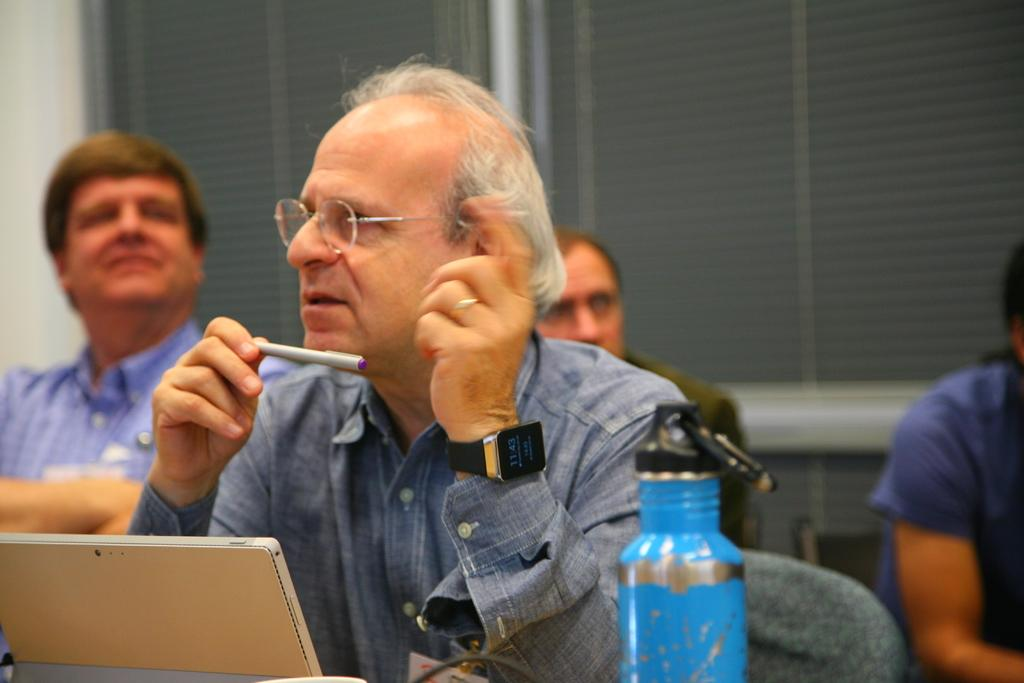What is the man in the image doing? The man is sitting on a chair in the image. Who or what is the man looking at? The man is looking at someone. Can you describe the people in the background of the image? There are three people in the background of the image. What type of crayon is the man using to draw in the image? There is no crayon or drawing activity present in the image. What activity are the waves participating in the image? There are no waves present in the image. 